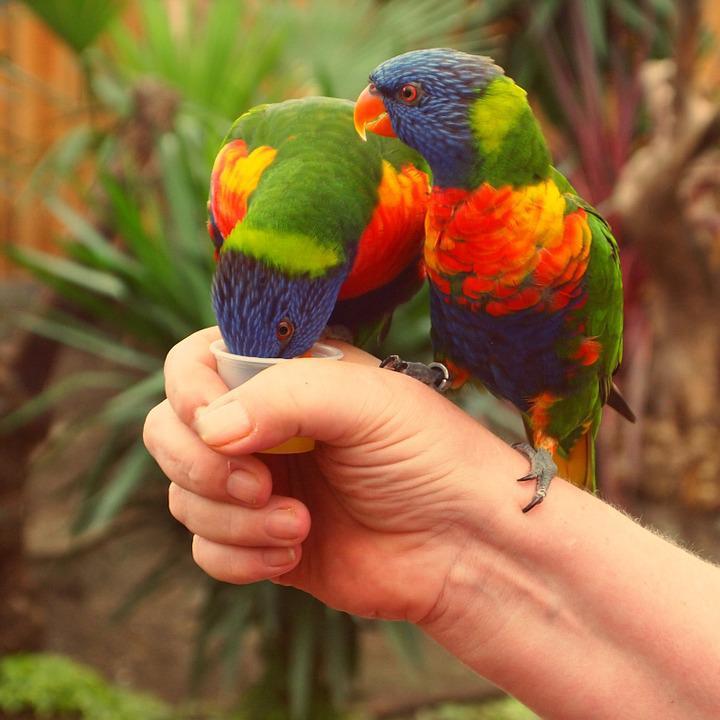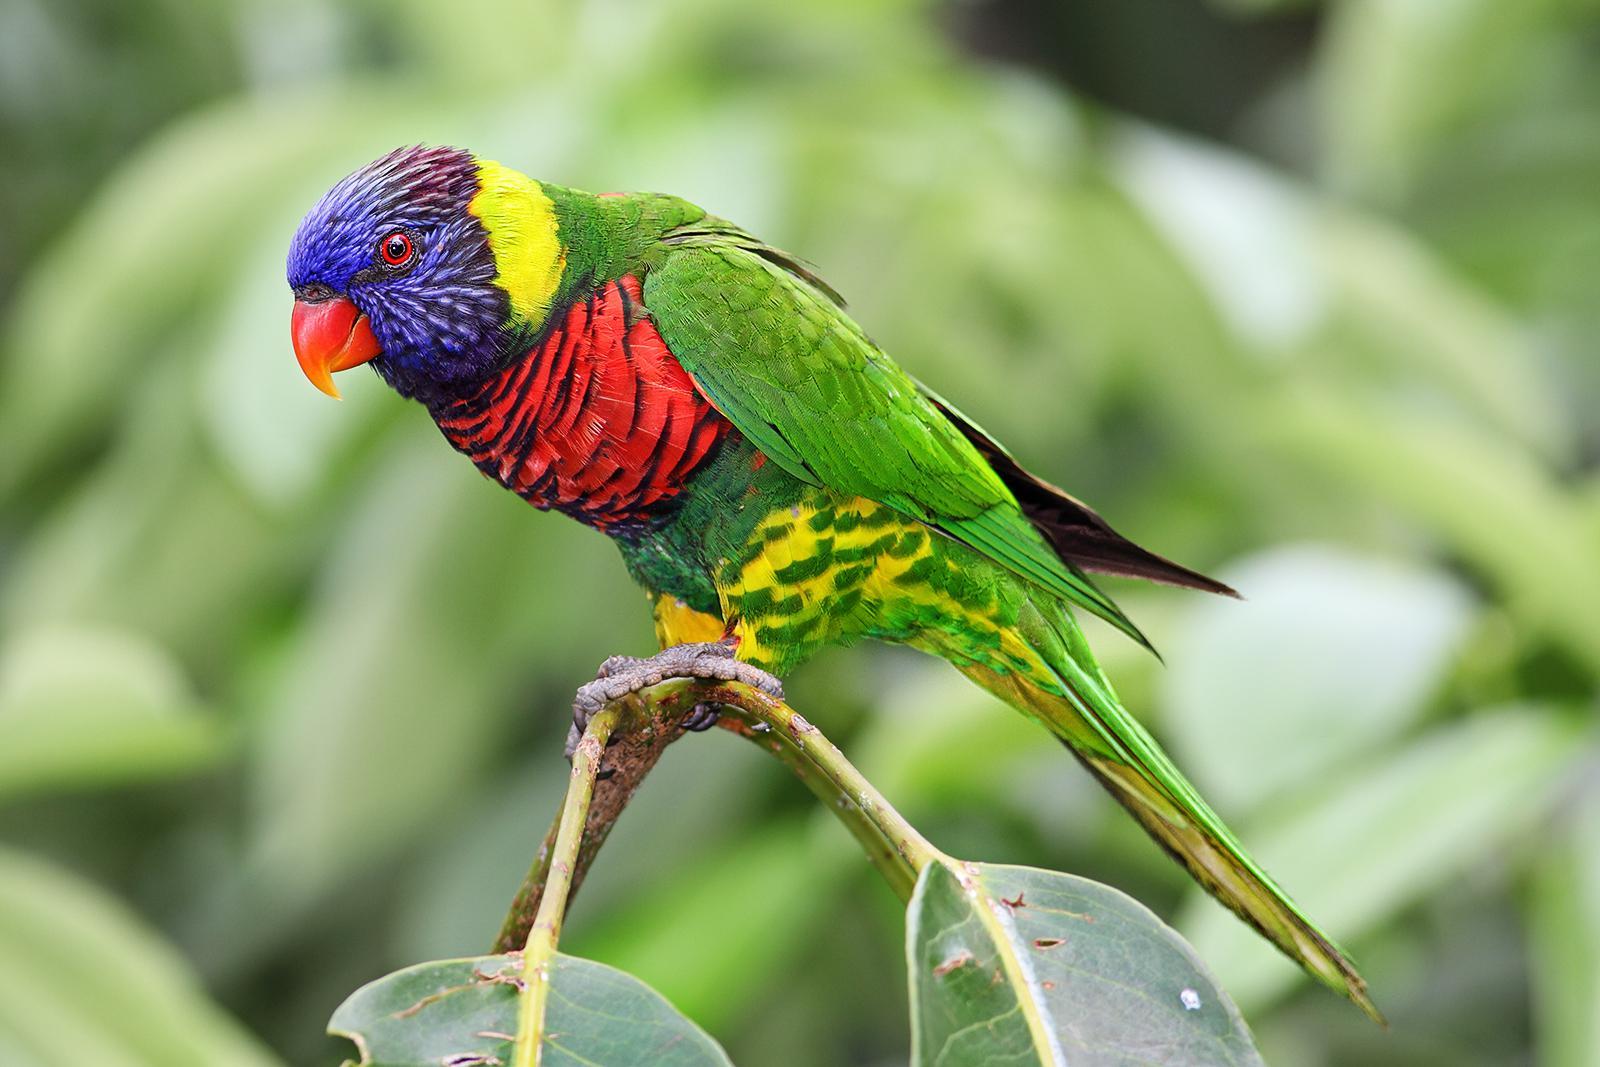The first image is the image on the left, the second image is the image on the right. Examine the images to the left and right. Is the description "There are more parrots in the left image." accurate? Answer yes or no. Yes. 